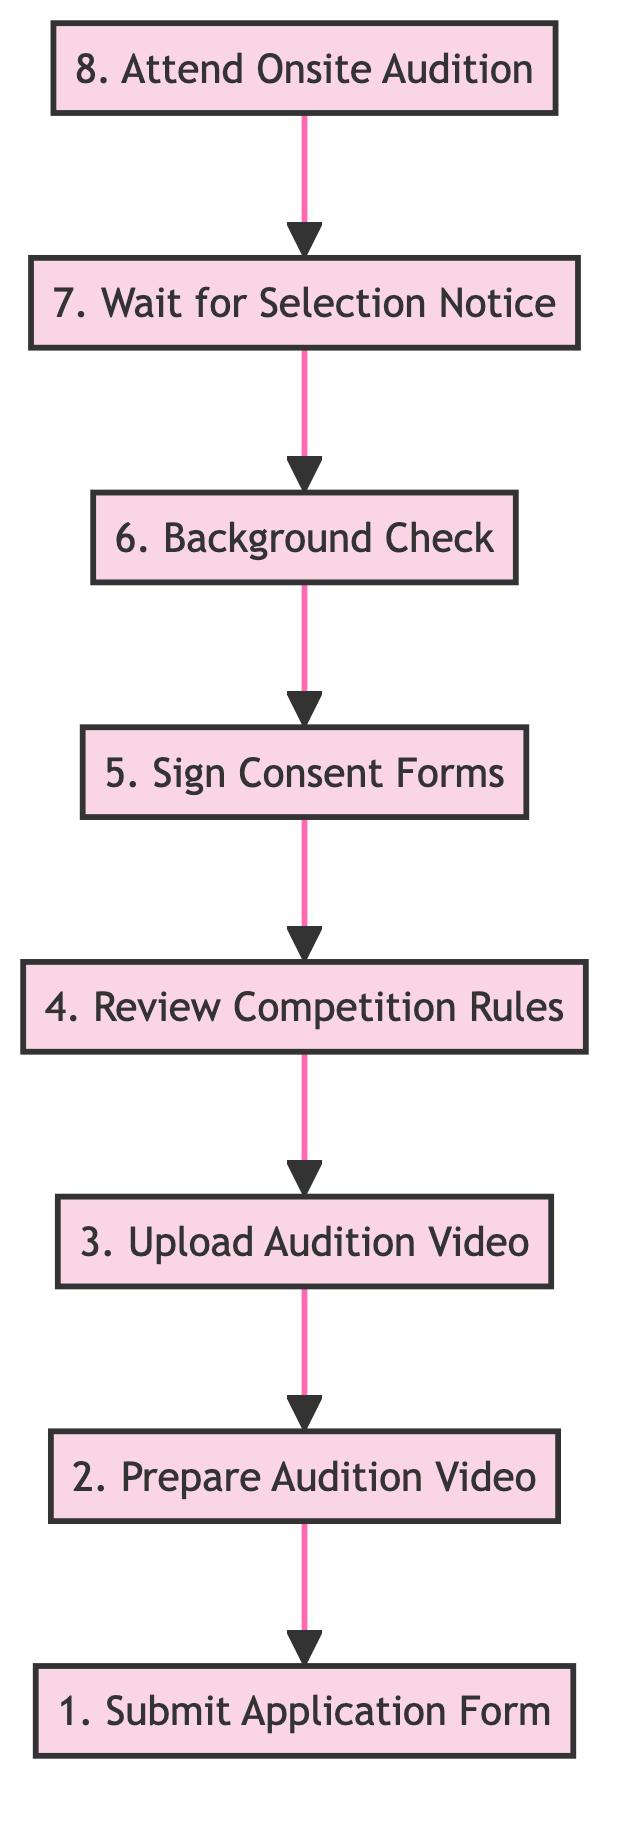What is the first step in the process? The first step in the process is to "Submit Application Form," which is the bottommost node in the flowchart.
Answer: Submit Application Form What is the last step in the process? The last step in the process is "Attend Onsite Audition," which is the topmost node in the flowchart.
Answer: Attend Onsite Audition How many steps are there in total? The flowchart contains eight distinct steps from "Submit Application Form" to "Attend Onsite Audition."
Answer: 8 What step follows "Review Competition Rules"? The step that follows "Review Competition Rules" is "Sign Consent Forms," as shown by the directional flow in the diagram.
Answer: Sign Consent Forms Which two steps are connected directly? Each step connects to the next, including "Prepare Audition Video" and "Upload Audition Video," as indicated by the flow direction.
Answer: Prepare Audition Video, Upload Audition Video What must be done before attending the onsite audition? Before attending the onsite audition, you need to wait for the selection notice, as indicated by the sequence of steps in the diagram.
Answer: Wait for Selection Notice What is the relationship between "Background Check" and "Sign Consent Forms"? "Background Check" is a step that occurs after "Sign Consent Forms," indicating that consent must be provided before the background review can take place.
Answer: Background Check is after Sign Consent Forms How does one submit their application video? One submits their audition video by uploading it to the specified platform mentioned in the application form, following the step "Prepare Audition Video."
Answer: Upload Audition Video What is required before preparing the audition video? Before preparing the audition video, you must submit the application form since that is the first step in the flowchart.
Answer: Submit Application Form 